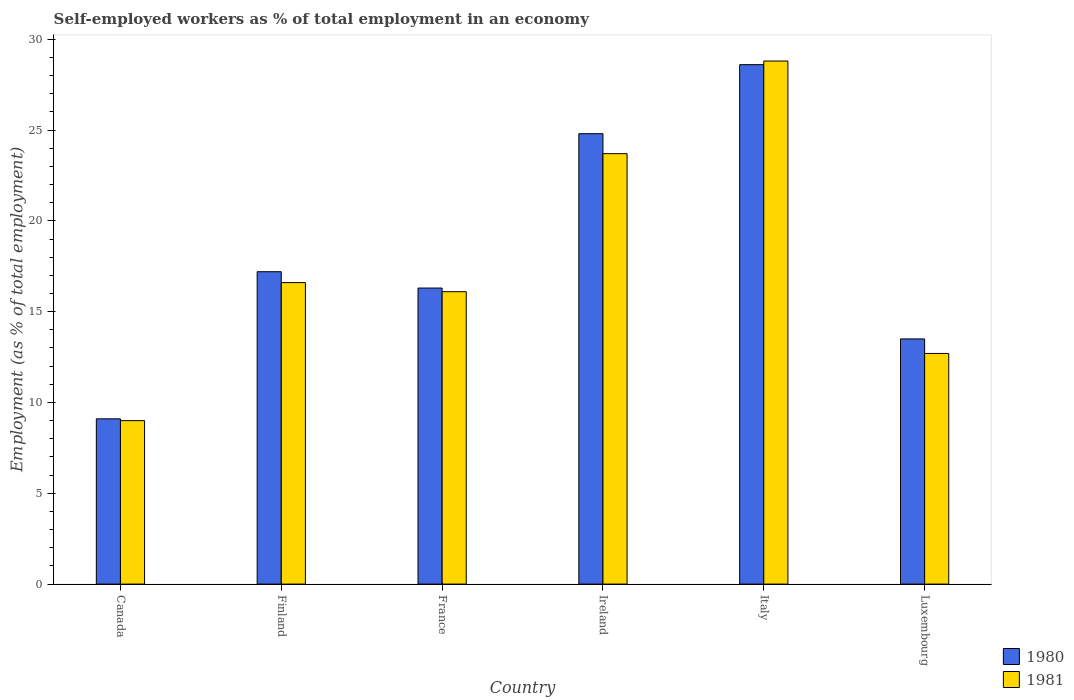How many different coloured bars are there?
Keep it short and to the point. 2. Are the number of bars per tick equal to the number of legend labels?
Provide a short and direct response. Yes. How many bars are there on the 2nd tick from the left?
Keep it short and to the point. 2. How many bars are there on the 4th tick from the right?
Ensure brevity in your answer.  2. What is the label of the 1st group of bars from the left?
Your response must be concise. Canada. What is the percentage of self-employed workers in 1981 in Ireland?
Keep it short and to the point. 23.7. Across all countries, what is the maximum percentage of self-employed workers in 1981?
Make the answer very short. 28.8. Across all countries, what is the minimum percentage of self-employed workers in 1980?
Your answer should be very brief. 9.1. In which country was the percentage of self-employed workers in 1981 maximum?
Ensure brevity in your answer.  Italy. In which country was the percentage of self-employed workers in 1980 minimum?
Give a very brief answer. Canada. What is the total percentage of self-employed workers in 1980 in the graph?
Make the answer very short. 109.5. What is the difference between the percentage of self-employed workers in 1981 in France and that in Italy?
Provide a succinct answer. -12.7. What is the difference between the percentage of self-employed workers in 1980 in Luxembourg and the percentage of self-employed workers in 1981 in Ireland?
Your answer should be compact. -10.2. What is the average percentage of self-employed workers in 1981 per country?
Provide a succinct answer. 17.82. What is the difference between the percentage of self-employed workers of/in 1980 and percentage of self-employed workers of/in 1981 in Ireland?
Your answer should be compact. 1.1. What is the ratio of the percentage of self-employed workers in 1981 in Finland to that in France?
Make the answer very short. 1.03. What is the difference between the highest and the second highest percentage of self-employed workers in 1980?
Give a very brief answer. 7.6. What is the difference between the highest and the lowest percentage of self-employed workers in 1980?
Provide a short and direct response. 19.5. In how many countries, is the percentage of self-employed workers in 1981 greater than the average percentage of self-employed workers in 1981 taken over all countries?
Ensure brevity in your answer.  2. What does the 2nd bar from the left in Canada represents?
Your response must be concise. 1981. How many bars are there?
Give a very brief answer. 12. Are all the bars in the graph horizontal?
Provide a short and direct response. No. How many countries are there in the graph?
Keep it short and to the point. 6. Are the values on the major ticks of Y-axis written in scientific E-notation?
Provide a short and direct response. No. Does the graph contain grids?
Your response must be concise. No. How are the legend labels stacked?
Offer a very short reply. Vertical. What is the title of the graph?
Provide a short and direct response. Self-employed workers as % of total employment in an economy. Does "1992" appear as one of the legend labels in the graph?
Your response must be concise. No. What is the label or title of the X-axis?
Offer a terse response. Country. What is the label or title of the Y-axis?
Your answer should be compact. Employment (as % of total employment). What is the Employment (as % of total employment) of 1980 in Canada?
Give a very brief answer. 9.1. What is the Employment (as % of total employment) in 1980 in Finland?
Ensure brevity in your answer.  17.2. What is the Employment (as % of total employment) of 1981 in Finland?
Your answer should be very brief. 16.6. What is the Employment (as % of total employment) of 1980 in France?
Give a very brief answer. 16.3. What is the Employment (as % of total employment) in 1981 in France?
Provide a succinct answer. 16.1. What is the Employment (as % of total employment) in 1980 in Ireland?
Provide a short and direct response. 24.8. What is the Employment (as % of total employment) in 1981 in Ireland?
Ensure brevity in your answer.  23.7. What is the Employment (as % of total employment) of 1980 in Italy?
Your response must be concise. 28.6. What is the Employment (as % of total employment) in 1981 in Italy?
Your response must be concise. 28.8. What is the Employment (as % of total employment) of 1980 in Luxembourg?
Make the answer very short. 13.5. What is the Employment (as % of total employment) of 1981 in Luxembourg?
Keep it short and to the point. 12.7. Across all countries, what is the maximum Employment (as % of total employment) in 1980?
Your answer should be compact. 28.6. Across all countries, what is the maximum Employment (as % of total employment) in 1981?
Keep it short and to the point. 28.8. Across all countries, what is the minimum Employment (as % of total employment) of 1980?
Your answer should be compact. 9.1. What is the total Employment (as % of total employment) of 1980 in the graph?
Offer a terse response. 109.5. What is the total Employment (as % of total employment) in 1981 in the graph?
Give a very brief answer. 106.9. What is the difference between the Employment (as % of total employment) in 1980 in Canada and that in France?
Your answer should be compact. -7.2. What is the difference between the Employment (as % of total employment) of 1981 in Canada and that in France?
Your response must be concise. -7.1. What is the difference between the Employment (as % of total employment) in 1980 in Canada and that in Ireland?
Offer a very short reply. -15.7. What is the difference between the Employment (as % of total employment) in 1981 in Canada and that in Ireland?
Ensure brevity in your answer.  -14.7. What is the difference between the Employment (as % of total employment) of 1980 in Canada and that in Italy?
Your answer should be compact. -19.5. What is the difference between the Employment (as % of total employment) in 1981 in Canada and that in Italy?
Your response must be concise. -19.8. What is the difference between the Employment (as % of total employment) in 1981 in Canada and that in Luxembourg?
Keep it short and to the point. -3.7. What is the difference between the Employment (as % of total employment) of 1980 in Finland and that in France?
Your answer should be very brief. 0.9. What is the difference between the Employment (as % of total employment) in 1981 in Finland and that in France?
Your answer should be very brief. 0.5. What is the difference between the Employment (as % of total employment) of 1980 in Finland and that in Ireland?
Offer a very short reply. -7.6. What is the difference between the Employment (as % of total employment) of 1981 in Finland and that in Ireland?
Your answer should be very brief. -7.1. What is the difference between the Employment (as % of total employment) of 1980 in France and that in Ireland?
Ensure brevity in your answer.  -8.5. What is the difference between the Employment (as % of total employment) of 1981 in France and that in Ireland?
Give a very brief answer. -7.6. What is the difference between the Employment (as % of total employment) of 1981 in France and that in Italy?
Offer a very short reply. -12.7. What is the difference between the Employment (as % of total employment) of 1980 in Ireland and that in Luxembourg?
Your response must be concise. 11.3. What is the difference between the Employment (as % of total employment) in 1981 in Ireland and that in Luxembourg?
Give a very brief answer. 11. What is the difference between the Employment (as % of total employment) in 1981 in Italy and that in Luxembourg?
Offer a very short reply. 16.1. What is the difference between the Employment (as % of total employment) of 1980 in Canada and the Employment (as % of total employment) of 1981 in Ireland?
Your answer should be very brief. -14.6. What is the difference between the Employment (as % of total employment) in 1980 in Canada and the Employment (as % of total employment) in 1981 in Italy?
Ensure brevity in your answer.  -19.7. What is the difference between the Employment (as % of total employment) in 1980 in Canada and the Employment (as % of total employment) in 1981 in Luxembourg?
Offer a very short reply. -3.6. What is the difference between the Employment (as % of total employment) in 1980 in Finland and the Employment (as % of total employment) in 1981 in Ireland?
Offer a very short reply. -6.5. What is the difference between the Employment (as % of total employment) in 1980 in Finland and the Employment (as % of total employment) in 1981 in Italy?
Give a very brief answer. -11.6. What is the difference between the Employment (as % of total employment) of 1980 in France and the Employment (as % of total employment) of 1981 in Ireland?
Offer a terse response. -7.4. What is the difference between the Employment (as % of total employment) in 1980 in France and the Employment (as % of total employment) in 1981 in Italy?
Ensure brevity in your answer.  -12.5. What is the difference between the Employment (as % of total employment) of 1980 in Ireland and the Employment (as % of total employment) of 1981 in Italy?
Your answer should be compact. -4. What is the average Employment (as % of total employment) in 1980 per country?
Make the answer very short. 18.25. What is the average Employment (as % of total employment) in 1981 per country?
Keep it short and to the point. 17.82. What is the difference between the Employment (as % of total employment) in 1980 and Employment (as % of total employment) in 1981 in Canada?
Provide a succinct answer. 0.1. What is the difference between the Employment (as % of total employment) of 1980 and Employment (as % of total employment) of 1981 in France?
Your answer should be very brief. 0.2. What is the difference between the Employment (as % of total employment) of 1980 and Employment (as % of total employment) of 1981 in Ireland?
Your response must be concise. 1.1. What is the difference between the Employment (as % of total employment) in 1980 and Employment (as % of total employment) in 1981 in Luxembourg?
Keep it short and to the point. 0.8. What is the ratio of the Employment (as % of total employment) in 1980 in Canada to that in Finland?
Your answer should be very brief. 0.53. What is the ratio of the Employment (as % of total employment) of 1981 in Canada to that in Finland?
Provide a succinct answer. 0.54. What is the ratio of the Employment (as % of total employment) of 1980 in Canada to that in France?
Provide a short and direct response. 0.56. What is the ratio of the Employment (as % of total employment) in 1981 in Canada to that in France?
Ensure brevity in your answer.  0.56. What is the ratio of the Employment (as % of total employment) of 1980 in Canada to that in Ireland?
Keep it short and to the point. 0.37. What is the ratio of the Employment (as % of total employment) of 1981 in Canada to that in Ireland?
Your answer should be very brief. 0.38. What is the ratio of the Employment (as % of total employment) in 1980 in Canada to that in Italy?
Your response must be concise. 0.32. What is the ratio of the Employment (as % of total employment) in 1981 in Canada to that in Italy?
Your answer should be very brief. 0.31. What is the ratio of the Employment (as % of total employment) in 1980 in Canada to that in Luxembourg?
Make the answer very short. 0.67. What is the ratio of the Employment (as % of total employment) in 1981 in Canada to that in Luxembourg?
Offer a very short reply. 0.71. What is the ratio of the Employment (as % of total employment) of 1980 in Finland to that in France?
Your response must be concise. 1.06. What is the ratio of the Employment (as % of total employment) in 1981 in Finland to that in France?
Your response must be concise. 1.03. What is the ratio of the Employment (as % of total employment) in 1980 in Finland to that in Ireland?
Provide a succinct answer. 0.69. What is the ratio of the Employment (as % of total employment) of 1981 in Finland to that in Ireland?
Offer a terse response. 0.7. What is the ratio of the Employment (as % of total employment) in 1980 in Finland to that in Italy?
Give a very brief answer. 0.6. What is the ratio of the Employment (as % of total employment) of 1981 in Finland to that in Italy?
Offer a very short reply. 0.58. What is the ratio of the Employment (as % of total employment) in 1980 in Finland to that in Luxembourg?
Make the answer very short. 1.27. What is the ratio of the Employment (as % of total employment) in 1981 in Finland to that in Luxembourg?
Your answer should be very brief. 1.31. What is the ratio of the Employment (as % of total employment) in 1980 in France to that in Ireland?
Give a very brief answer. 0.66. What is the ratio of the Employment (as % of total employment) of 1981 in France to that in Ireland?
Your answer should be very brief. 0.68. What is the ratio of the Employment (as % of total employment) of 1980 in France to that in Italy?
Ensure brevity in your answer.  0.57. What is the ratio of the Employment (as % of total employment) of 1981 in France to that in Italy?
Ensure brevity in your answer.  0.56. What is the ratio of the Employment (as % of total employment) in 1980 in France to that in Luxembourg?
Provide a short and direct response. 1.21. What is the ratio of the Employment (as % of total employment) of 1981 in France to that in Luxembourg?
Your answer should be compact. 1.27. What is the ratio of the Employment (as % of total employment) in 1980 in Ireland to that in Italy?
Provide a succinct answer. 0.87. What is the ratio of the Employment (as % of total employment) of 1981 in Ireland to that in Italy?
Your answer should be compact. 0.82. What is the ratio of the Employment (as % of total employment) of 1980 in Ireland to that in Luxembourg?
Ensure brevity in your answer.  1.84. What is the ratio of the Employment (as % of total employment) of 1981 in Ireland to that in Luxembourg?
Keep it short and to the point. 1.87. What is the ratio of the Employment (as % of total employment) of 1980 in Italy to that in Luxembourg?
Make the answer very short. 2.12. What is the ratio of the Employment (as % of total employment) of 1981 in Italy to that in Luxembourg?
Provide a short and direct response. 2.27. What is the difference between the highest and the lowest Employment (as % of total employment) in 1981?
Ensure brevity in your answer.  19.8. 